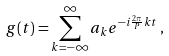Convert formula to latex. <formula><loc_0><loc_0><loc_500><loc_500>g ( t ) = \sum ^ { \infty } _ { k = - \infty } a _ { k } e ^ { - i \frac { 2 \pi } { P } k t } \, ,</formula> 